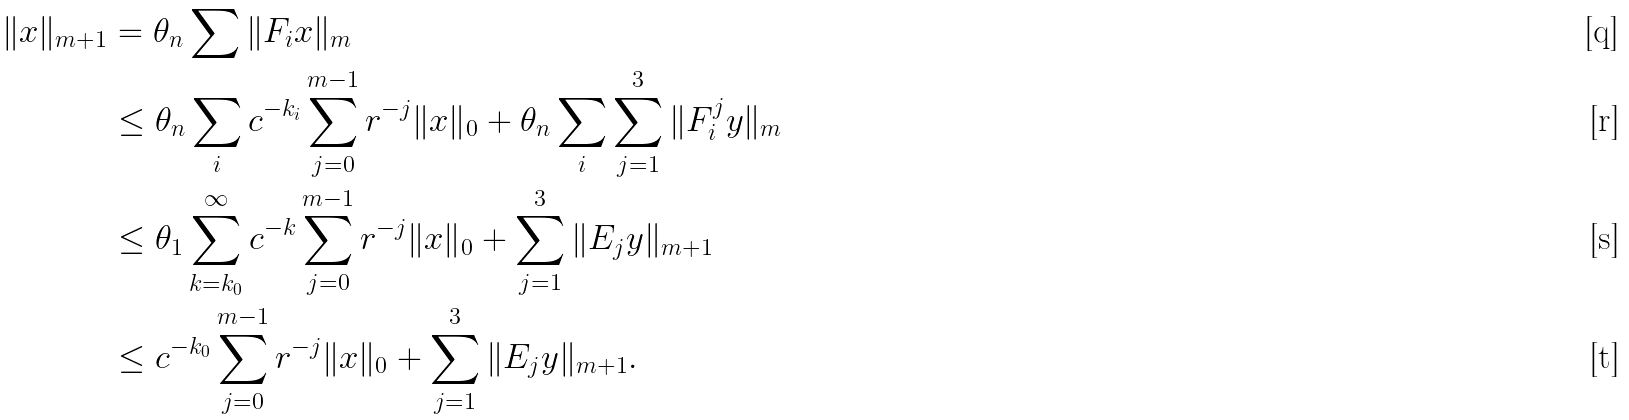<formula> <loc_0><loc_0><loc_500><loc_500>\| x \| _ { m + 1 } & = \theta _ { n } \sum \| F _ { i } x \| _ { m } \\ & \leq \theta _ { n } \sum _ { i } c ^ { - k _ { i } } \sum ^ { m - 1 } _ { j = 0 } r ^ { - j } \| x \| _ { 0 } + \theta _ { n } \sum _ { i } \sum ^ { 3 } _ { j = 1 } \| F ^ { j } _ { i } y \| _ { m } \\ & \leq \theta _ { 1 } \sum ^ { \infty } _ { k = k _ { 0 } } c ^ { - k } \sum ^ { m - 1 } _ { j = 0 } r ^ { - j } \| x \| _ { 0 } + \sum ^ { 3 } _ { j = 1 } \| E _ { j } y \| _ { m + 1 } \\ & \leq c ^ { - k _ { 0 } } \sum ^ { m - 1 } _ { j = 0 } r ^ { - j } \| x \| _ { 0 } + \sum ^ { 3 } _ { j = 1 } \| E _ { j } y \| _ { m + 1 } .</formula> 